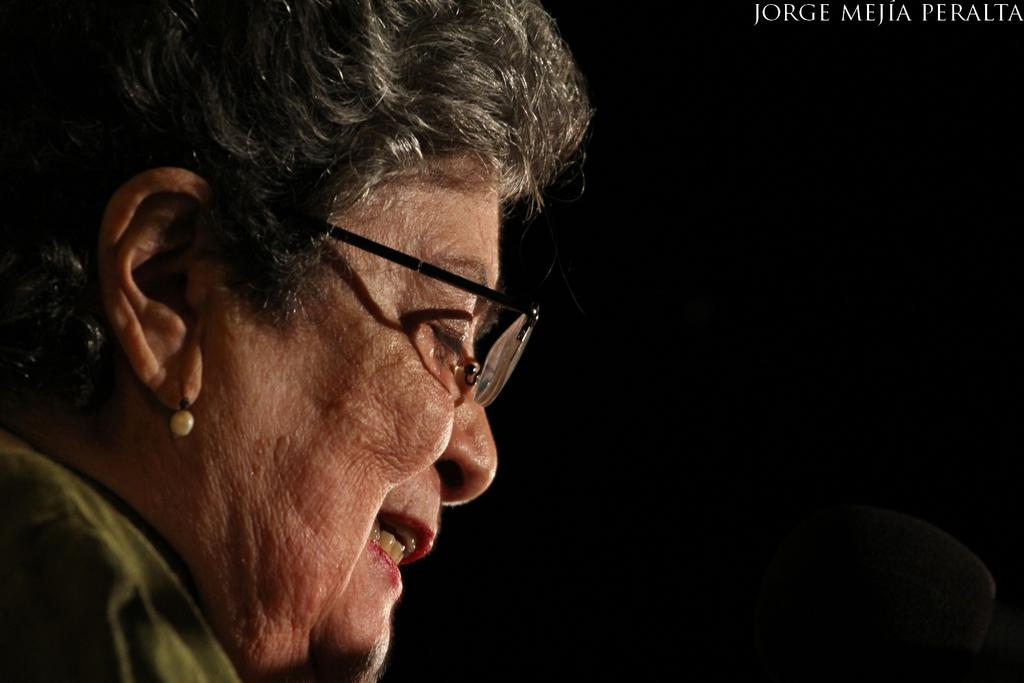What is the person in the image wearing on their face? The person in the image is wearing spectacles. How would you describe the overall lighting in the image? The background of the image is dark. Where can you find text in the image? Text is visible in the top right side of the image. Can you see any squirrels or blood in the image? No, there are no squirrels or blood present in the image. How many cakes are visible in the image? There are no cakes present in the image. 